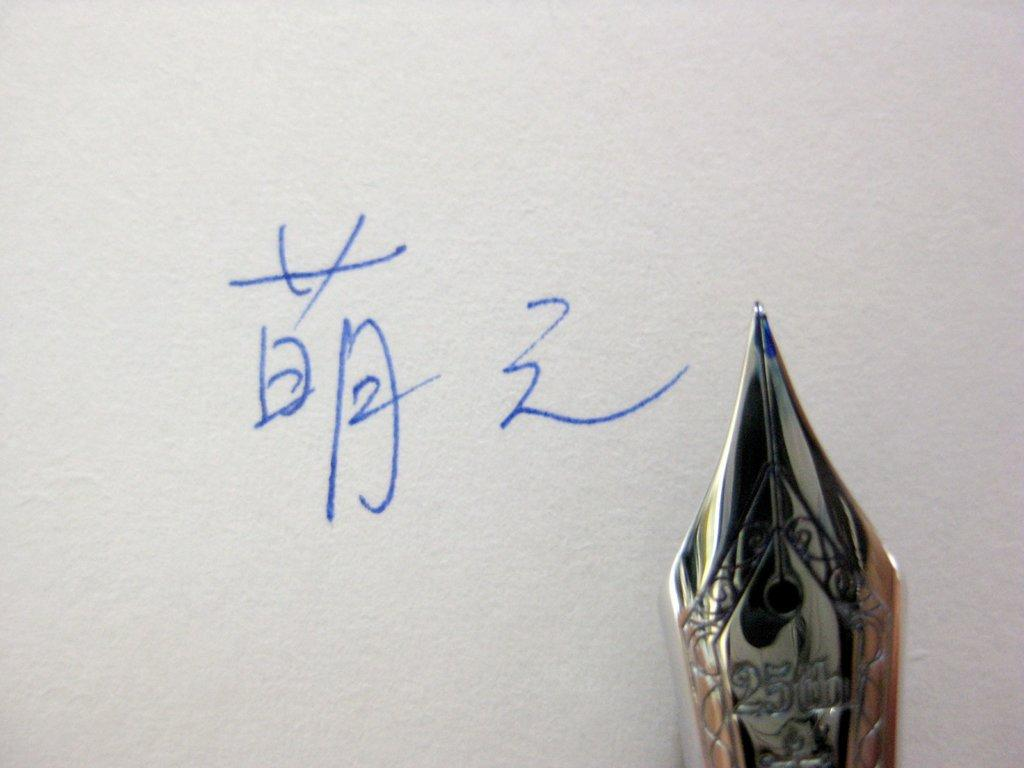What object is visible in the image? There is a pen in the image. What is the pen resting on? The pen is on a white surface. Is there any text or drawing visible on the white surface? Yes, there is writing on the white surface. What type of corn is being harvested in the image? There is no corn present in the image; it features a pen on a white surface with writing. What color is the copper in the image? There is no copper present in the image. 